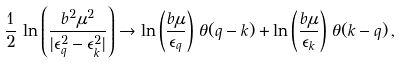<formula> <loc_0><loc_0><loc_500><loc_500>\frac { 1 } { 2 } \, \ln \left ( \frac { b ^ { 2 } \mu ^ { 2 } } { | \epsilon _ { q } ^ { 2 } - \epsilon _ { k } ^ { 2 } | } \right ) \rightarrow \ln \left ( \frac { b \mu } { \epsilon _ { q } } \right ) \, \theta ( q - k ) + \ln \left ( \frac { b \mu } { \epsilon _ { k } } \right ) \, \theta ( k - q ) \, ,</formula> 